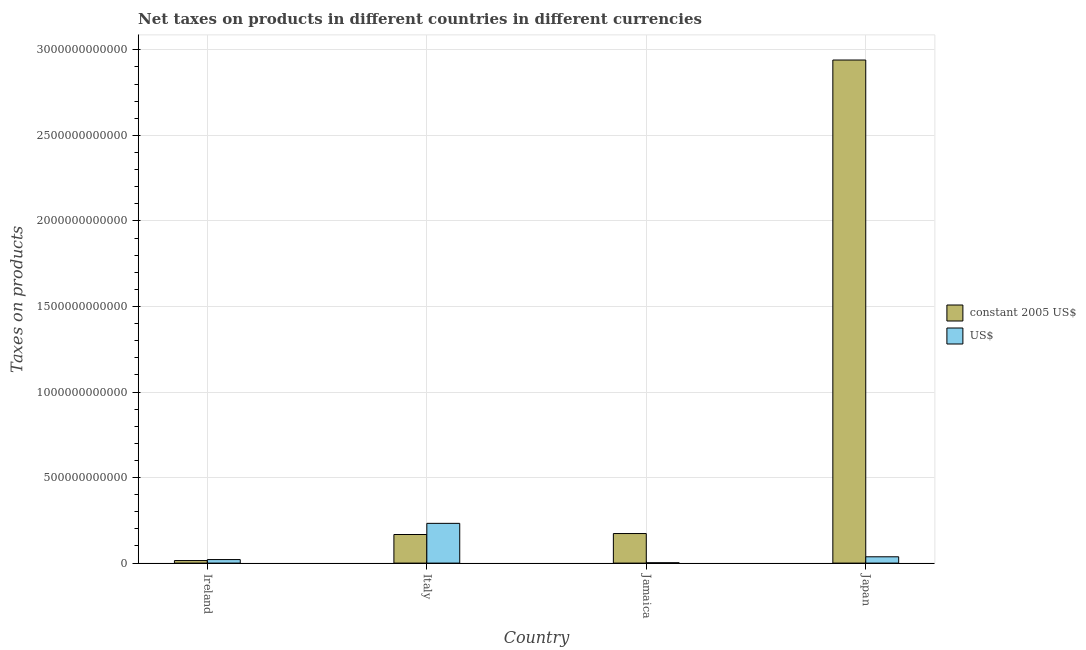How many different coloured bars are there?
Offer a very short reply. 2. How many groups of bars are there?
Ensure brevity in your answer.  4. Are the number of bars per tick equal to the number of legend labels?
Make the answer very short. Yes. How many bars are there on the 4th tick from the left?
Your answer should be very brief. 2. What is the label of the 3rd group of bars from the left?
Make the answer very short. Jamaica. What is the net taxes in us$ in Italy?
Offer a very short reply. 2.32e+11. Across all countries, what is the maximum net taxes in constant 2005 us$?
Offer a terse response. 2.94e+12. Across all countries, what is the minimum net taxes in constant 2005 us$?
Give a very brief answer. 1.49e+1. In which country was the net taxes in us$ maximum?
Give a very brief answer. Italy. In which country was the net taxes in constant 2005 us$ minimum?
Keep it short and to the point. Ireland. What is the total net taxes in constant 2005 us$ in the graph?
Make the answer very short. 3.30e+12. What is the difference between the net taxes in constant 2005 us$ in Ireland and that in Italy?
Ensure brevity in your answer.  -1.52e+11. What is the difference between the net taxes in constant 2005 us$ in Japan and the net taxes in us$ in Jamaica?
Your answer should be compact. 2.94e+12. What is the average net taxes in us$ per country?
Provide a short and direct response. 7.30e+1. What is the difference between the net taxes in us$ and net taxes in constant 2005 us$ in Ireland?
Provide a succinct answer. 5.80e+09. In how many countries, is the net taxes in constant 2005 us$ greater than 2800000000000 units?
Your answer should be very brief. 1. What is the ratio of the net taxes in constant 2005 us$ in Ireland to that in Italy?
Provide a short and direct response. 0.09. Is the net taxes in constant 2005 us$ in Ireland less than that in Jamaica?
Offer a terse response. Yes. What is the difference between the highest and the second highest net taxes in us$?
Give a very brief answer. 1.95e+11. What is the difference between the highest and the lowest net taxes in us$?
Give a very brief answer. 2.30e+11. In how many countries, is the net taxes in us$ greater than the average net taxes in us$ taken over all countries?
Provide a succinct answer. 1. What does the 1st bar from the left in Japan represents?
Provide a short and direct response. Constant 2005 us$. What does the 1st bar from the right in Jamaica represents?
Keep it short and to the point. US$. How many bars are there?
Give a very brief answer. 8. Are all the bars in the graph horizontal?
Make the answer very short. No. How many countries are there in the graph?
Your answer should be compact. 4. What is the difference between two consecutive major ticks on the Y-axis?
Provide a succinct answer. 5.00e+11. Are the values on the major ticks of Y-axis written in scientific E-notation?
Offer a very short reply. No. Does the graph contain any zero values?
Give a very brief answer. No. Does the graph contain grids?
Your answer should be very brief. Yes. How are the legend labels stacked?
Ensure brevity in your answer.  Vertical. What is the title of the graph?
Offer a very short reply. Net taxes on products in different countries in different currencies. Does "Central government" appear as one of the legend labels in the graph?
Make the answer very short. No. What is the label or title of the X-axis?
Your answer should be compact. Country. What is the label or title of the Y-axis?
Provide a short and direct response. Taxes on products. What is the Taxes on products of constant 2005 US$ in Ireland?
Offer a very short reply. 1.49e+1. What is the Taxes on products in US$ in Ireland?
Provide a succinct answer. 2.07e+1. What is the Taxes on products of constant 2005 US$ in Italy?
Make the answer very short. 1.67e+11. What is the Taxes on products of US$ in Italy?
Make the answer very short. 2.32e+11. What is the Taxes on products in constant 2005 US$ in Jamaica?
Your answer should be compact. 1.73e+11. What is the Taxes on products in US$ in Jamaica?
Ensure brevity in your answer.  2.01e+09. What is the Taxes on products in constant 2005 US$ in Japan?
Make the answer very short. 2.94e+12. What is the Taxes on products of US$ in Japan?
Offer a very short reply. 3.68e+1. Across all countries, what is the maximum Taxes on products of constant 2005 US$?
Offer a terse response. 2.94e+12. Across all countries, what is the maximum Taxes on products of US$?
Make the answer very short. 2.32e+11. Across all countries, what is the minimum Taxes on products in constant 2005 US$?
Ensure brevity in your answer.  1.49e+1. Across all countries, what is the minimum Taxes on products in US$?
Your answer should be compact. 2.01e+09. What is the total Taxes on products in constant 2005 US$ in the graph?
Your answer should be very brief. 3.30e+12. What is the total Taxes on products of US$ in the graph?
Your answer should be compact. 2.92e+11. What is the difference between the Taxes on products of constant 2005 US$ in Ireland and that in Italy?
Your response must be concise. -1.52e+11. What is the difference between the Taxes on products in US$ in Ireland and that in Italy?
Make the answer very short. -2.12e+11. What is the difference between the Taxes on products of constant 2005 US$ in Ireland and that in Jamaica?
Give a very brief answer. -1.58e+11. What is the difference between the Taxes on products of US$ in Ireland and that in Jamaica?
Your answer should be very brief. 1.86e+1. What is the difference between the Taxes on products of constant 2005 US$ in Ireland and that in Japan?
Make the answer very short. -2.93e+12. What is the difference between the Taxes on products in US$ in Ireland and that in Japan?
Offer a terse response. -1.62e+1. What is the difference between the Taxes on products of constant 2005 US$ in Italy and that in Jamaica?
Give a very brief answer. -5.66e+09. What is the difference between the Taxes on products in US$ in Italy and that in Jamaica?
Keep it short and to the point. 2.30e+11. What is the difference between the Taxes on products in constant 2005 US$ in Italy and that in Japan?
Your response must be concise. -2.77e+12. What is the difference between the Taxes on products of US$ in Italy and that in Japan?
Keep it short and to the point. 1.95e+11. What is the difference between the Taxes on products in constant 2005 US$ in Jamaica and that in Japan?
Ensure brevity in your answer.  -2.77e+12. What is the difference between the Taxes on products in US$ in Jamaica and that in Japan?
Provide a succinct answer. -3.48e+1. What is the difference between the Taxes on products of constant 2005 US$ in Ireland and the Taxes on products of US$ in Italy?
Your answer should be compact. -2.17e+11. What is the difference between the Taxes on products in constant 2005 US$ in Ireland and the Taxes on products in US$ in Jamaica?
Ensure brevity in your answer.  1.29e+1. What is the difference between the Taxes on products of constant 2005 US$ in Ireland and the Taxes on products of US$ in Japan?
Your response must be concise. -2.20e+1. What is the difference between the Taxes on products of constant 2005 US$ in Italy and the Taxes on products of US$ in Jamaica?
Your answer should be compact. 1.65e+11. What is the difference between the Taxes on products in constant 2005 US$ in Italy and the Taxes on products in US$ in Japan?
Your response must be concise. 1.30e+11. What is the difference between the Taxes on products in constant 2005 US$ in Jamaica and the Taxes on products in US$ in Japan?
Give a very brief answer. 1.36e+11. What is the average Taxes on products in constant 2005 US$ per country?
Offer a terse response. 8.24e+11. What is the average Taxes on products in US$ per country?
Offer a very short reply. 7.30e+1. What is the difference between the Taxes on products of constant 2005 US$ and Taxes on products of US$ in Ireland?
Keep it short and to the point. -5.80e+09. What is the difference between the Taxes on products of constant 2005 US$ and Taxes on products of US$ in Italy?
Offer a very short reply. -6.52e+1. What is the difference between the Taxes on products of constant 2005 US$ and Taxes on products of US$ in Jamaica?
Provide a succinct answer. 1.71e+11. What is the difference between the Taxes on products in constant 2005 US$ and Taxes on products in US$ in Japan?
Your answer should be very brief. 2.90e+12. What is the ratio of the Taxes on products in constant 2005 US$ in Ireland to that in Italy?
Offer a terse response. 0.09. What is the ratio of the Taxes on products of US$ in Ireland to that in Italy?
Keep it short and to the point. 0.09. What is the ratio of the Taxes on products of constant 2005 US$ in Ireland to that in Jamaica?
Your answer should be compact. 0.09. What is the ratio of the Taxes on products in US$ in Ireland to that in Jamaica?
Provide a succinct answer. 10.29. What is the ratio of the Taxes on products of constant 2005 US$ in Ireland to that in Japan?
Ensure brevity in your answer.  0.01. What is the ratio of the Taxes on products of US$ in Ireland to that in Japan?
Offer a terse response. 0.56. What is the ratio of the Taxes on products of constant 2005 US$ in Italy to that in Jamaica?
Ensure brevity in your answer.  0.97. What is the ratio of the Taxes on products in US$ in Italy to that in Jamaica?
Offer a terse response. 115.73. What is the ratio of the Taxes on products in constant 2005 US$ in Italy to that in Japan?
Ensure brevity in your answer.  0.06. What is the ratio of the Taxes on products of US$ in Italy to that in Japan?
Provide a succinct answer. 6.3. What is the ratio of the Taxes on products in constant 2005 US$ in Jamaica to that in Japan?
Keep it short and to the point. 0.06. What is the ratio of the Taxes on products of US$ in Jamaica to that in Japan?
Ensure brevity in your answer.  0.05. What is the difference between the highest and the second highest Taxes on products in constant 2005 US$?
Your answer should be compact. 2.77e+12. What is the difference between the highest and the second highest Taxes on products in US$?
Make the answer very short. 1.95e+11. What is the difference between the highest and the lowest Taxes on products in constant 2005 US$?
Offer a terse response. 2.93e+12. What is the difference between the highest and the lowest Taxes on products in US$?
Your answer should be compact. 2.30e+11. 